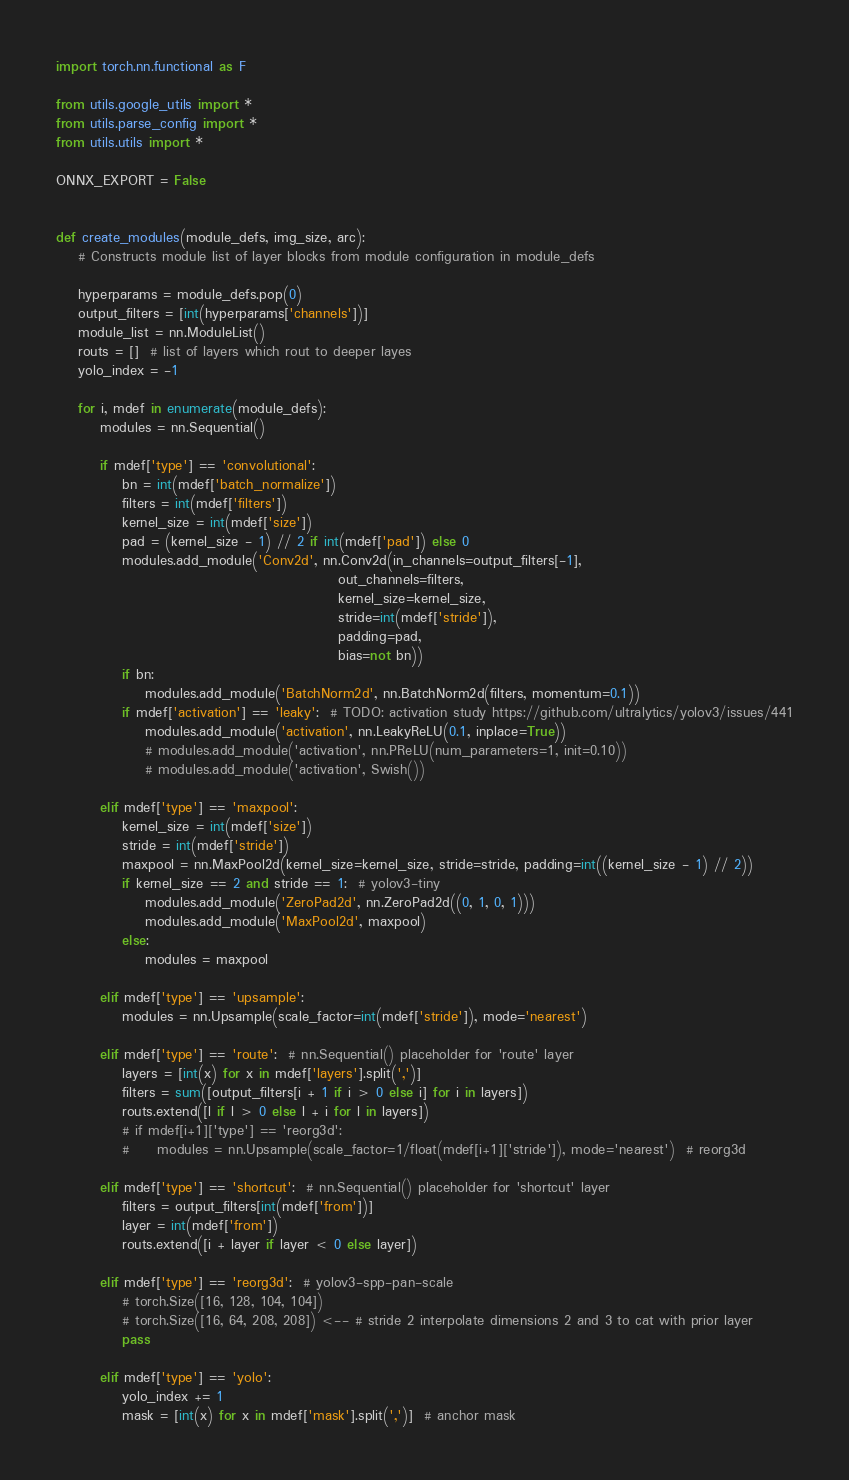Convert code to text. <code><loc_0><loc_0><loc_500><loc_500><_Python_>import torch.nn.functional as F

from utils.google_utils import *
from utils.parse_config import *
from utils.utils import *

ONNX_EXPORT = False


def create_modules(module_defs, img_size, arc):
    # Constructs module list of layer blocks from module configuration in module_defs

    hyperparams = module_defs.pop(0)
    output_filters = [int(hyperparams['channels'])]
    module_list = nn.ModuleList()
    routs = []  # list of layers which rout to deeper layes
    yolo_index = -1

    for i, mdef in enumerate(module_defs):
        modules = nn.Sequential()

        if mdef['type'] == 'convolutional':
            bn = int(mdef['batch_normalize'])
            filters = int(mdef['filters'])
            kernel_size = int(mdef['size'])
            pad = (kernel_size - 1) // 2 if int(mdef['pad']) else 0
            modules.add_module('Conv2d', nn.Conv2d(in_channels=output_filters[-1],
                                                   out_channels=filters,
                                                   kernel_size=kernel_size,
                                                   stride=int(mdef['stride']),
                                                   padding=pad,
                                                   bias=not bn))
            if bn:
                modules.add_module('BatchNorm2d', nn.BatchNorm2d(filters, momentum=0.1))
            if mdef['activation'] == 'leaky':  # TODO: activation study https://github.com/ultralytics/yolov3/issues/441
                modules.add_module('activation', nn.LeakyReLU(0.1, inplace=True))
                # modules.add_module('activation', nn.PReLU(num_parameters=1, init=0.10))
                # modules.add_module('activation', Swish())

        elif mdef['type'] == 'maxpool':
            kernel_size = int(mdef['size'])
            stride = int(mdef['stride'])
            maxpool = nn.MaxPool2d(kernel_size=kernel_size, stride=stride, padding=int((kernel_size - 1) // 2))
            if kernel_size == 2 and stride == 1:  # yolov3-tiny
                modules.add_module('ZeroPad2d', nn.ZeroPad2d((0, 1, 0, 1)))
                modules.add_module('MaxPool2d', maxpool)
            else:
                modules = maxpool

        elif mdef['type'] == 'upsample':
            modules = nn.Upsample(scale_factor=int(mdef['stride']), mode='nearest')

        elif mdef['type'] == 'route':  # nn.Sequential() placeholder for 'route' layer
            layers = [int(x) for x in mdef['layers'].split(',')]
            filters = sum([output_filters[i + 1 if i > 0 else i] for i in layers])
            routs.extend([l if l > 0 else l + i for l in layers])
            # if mdef[i+1]['type'] == 'reorg3d':
            #     modules = nn.Upsample(scale_factor=1/float(mdef[i+1]['stride']), mode='nearest')  # reorg3d

        elif mdef['type'] == 'shortcut':  # nn.Sequential() placeholder for 'shortcut' layer
            filters = output_filters[int(mdef['from'])]
            layer = int(mdef['from'])
            routs.extend([i + layer if layer < 0 else layer])

        elif mdef['type'] == 'reorg3d':  # yolov3-spp-pan-scale
            # torch.Size([16, 128, 104, 104])
            # torch.Size([16, 64, 208, 208]) <-- # stride 2 interpolate dimensions 2 and 3 to cat with prior layer
            pass

        elif mdef['type'] == 'yolo':
            yolo_index += 1
            mask = [int(x) for x in mdef['mask'].split(',')]  # anchor mask</code> 